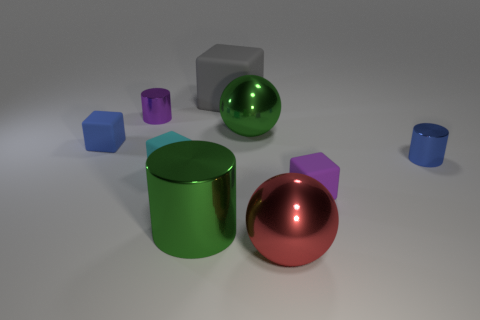Subtract all big green cylinders. How many cylinders are left? 2 Add 1 large green objects. How many objects exist? 10 Subtract all gray blocks. How many blocks are left? 3 Subtract all balls. How many objects are left? 7 Add 5 blue rubber cubes. How many blue rubber cubes are left? 6 Add 7 big gray rubber spheres. How many big gray rubber spheres exist? 7 Subtract 1 purple blocks. How many objects are left? 8 Subtract all brown blocks. Subtract all blue balls. How many blocks are left? 4 Subtract all big blue matte blocks. Subtract all small purple objects. How many objects are left? 7 